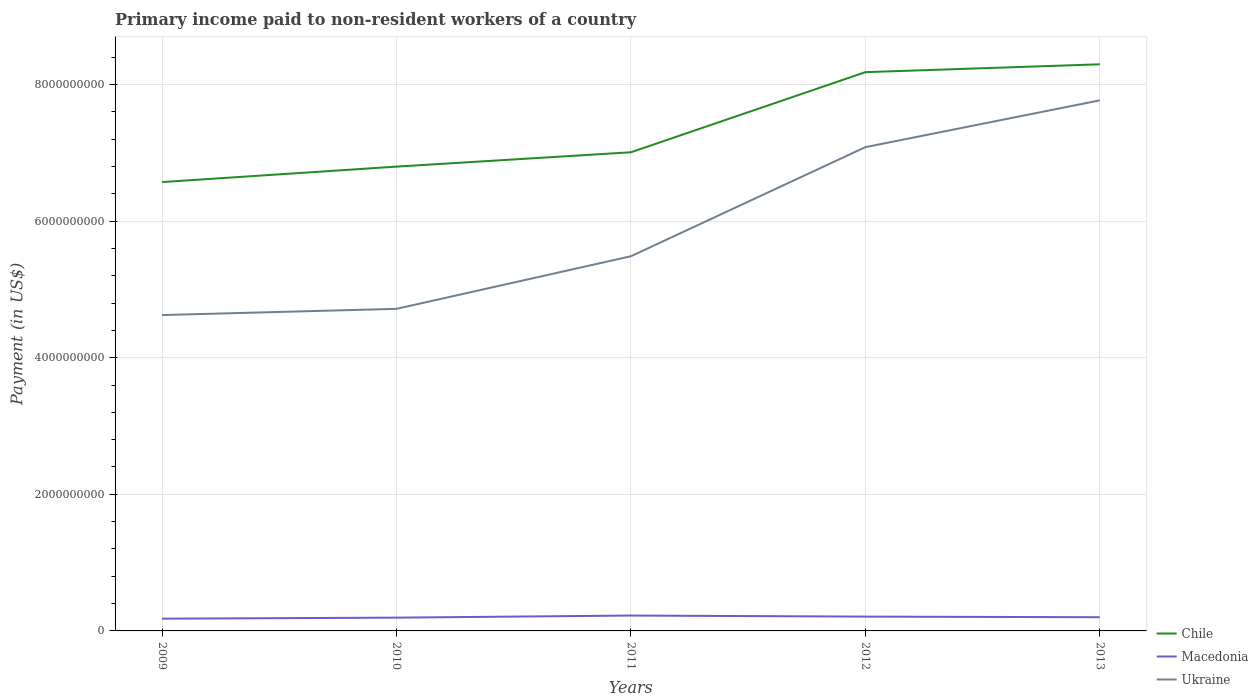Does the line corresponding to Macedonia intersect with the line corresponding to Ukraine?
Ensure brevity in your answer.  No. Across all years, what is the maximum amount paid to workers in Ukraine?
Provide a short and direct response. 4.62e+09. What is the total amount paid to workers in Macedonia in the graph?
Keep it short and to the point. 9.02e+06. What is the difference between the highest and the second highest amount paid to workers in Chile?
Your answer should be compact. 1.72e+09. Is the amount paid to workers in Ukraine strictly greater than the amount paid to workers in Macedonia over the years?
Make the answer very short. No. How many years are there in the graph?
Provide a succinct answer. 5. What is the difference between two consecutive major ticks on the Y-axis?
Keep it short and to the point. 2.00e+09. Where does the legend appear in the graph?
Your response must be concise. Bottom right. What is the title of the graph?
Your answer should be very brief. Primary income paid to non-resident workers of a country. What is the label or title of the Y-axis?
Offer a terse response. Payment (in US$). What is the Payment (in US$) in Chile in 2009?
Your answer should be compact. 6.57e+09. What is the Payment (in US$) in Macedonia in 2009?
Offer a very short reply. 1.79e+08. What is the Payment (in US$) in Ukraine in 2009?
Your response must be concise. 4.62e+09. What is the Payment (in US$) of Chile in 2010?
Your response must be concise. 6.80e+09. What is the Payment (in US$) of Macedonia in 2010?
Provide a succinct answer. 1.94e+08. What is the Payment (in US$) in Ukraine in 2010?
Give a very brief answer. 4.72e+09. What is the Payment (in US$) in Chile in 2011?
Make the answer very short. 7.01e+09. What is the Payment (in US$) in Macedonia in 2011?
Your answer should be very brief. 2.25e+08. What is the Payment (in US$) in Ukraine in 2011?
Keep it short and to the point. 5.48e+09. What is the Payment (in US$) of Chile in 2012?
Provide a short and direct response. 8.18e+09. What is the Payment (in US$) of Macedonia in 2012?
Give a very brief answer. 2.10e+08. What is the Payment (in US$) in Ukraine in 2012?
Your answer should be very brief. 7.08e+09. What is the Payment (in US$) in Chile in 2013?
Keep it short and to the point. 8.29e+09. What is the Payment (in US$) in Macedonia in 2013?
Ensure brevity in your answer.  2.01e+08. What is the Payment (in US$) in Ukraine in 2013?
Offer a very short reply. 7.77e+09. Across all years, what is the maximum Payment (in US$) in Chile?
Give a very brief answer. 8.29e+09. Across all years, what is the maximum Payment (in US$) in Macedonia?
Give a very brief answer. 2.25e+08. Across all years, what is the maximum Payment (in US$) of Ukraine?
Your response must be concise. 7.77e+09. Across all years, what is the minimum Payment (in US$) of Chile?
Offer a terse response. 6.57e+09. Across all years, what is the minimum Payment (in US$) of Macedonia?
Provide a succinct answer. 1.79e+08. Across all years, what is the minimum Payment (in US$) of Ukraine?
Your response must be concise. 4.62e+09. What is the total Payment (in US$) of Chile in the graph?
Make the answer very short. 3.68e+1. What is the total Payment (in US$) in Macedonia in the graph?
Your answer should be compact. 1.01e+09. What is the total Payment (in US$) of Ukraine in the graph?
Your answer should be compact. 2.97e+1. What is the difference between the Payment (in US$) in Chile in 2009 and that in 2010?
Your response must be concise. -2.26e+08. What is the difference between the Payment (in US$) in Macedonia in 2009 and that in 2010?
Offer a terse response. -1.49e+07. What is the difference between the Payment (in US$) in Ukraine in 2009 and that in 2010?
Keep it short and to the point. -9.10e+07. What is the difference between the Payment (in US$) of Chile in 2009 and that in 2011?
Your response must be concise. -4.36e+08. What is the difference between the Payment (in US$) in Macedonia in 2009 and that in 2011?
Keep it short and to the point. -4.56e+07. What is the difference between the Payment (in US$) of Ukraine in 2009 and that in 2011?
Ensure brevity in your answer.  -8.61e+08. What is the difference between the Payment (in US$) of Chile in 2009 and that in 2012?
Ensure brevity in your answer.  -1.61e+09. What is the difference between the Payment (in US$) in Macedonia in 2009 and that in 2012?
Provide a succinct answer. -3.01e+07. What is the difference between the Payment (in US$) in Ukraine in 2009 and that in 2012?
Offer a terse response. -2.46e+09. What is the difference between the Payment (in US$) of Chile in 2009 and that in 2013?
Your response must be concise. -1.72e+09. What is the difference between the Payment (in US$) of Macedonia in 2009 and that in 2013?
Offer a very short reply. -2.11e+07. What is the difference between the Payment (in US$) in Ukraine in 2009 and that in 2013?
Your response must be concise. -3.14e+09. What is the difference between the Payment (in US$) in Chile in 2010 and that in 2011?
Offer a terse response. -2.10e+08. What is the difference between the Payment (in US$) of Macedonia in 2010 and that in 2011?
Offer a terse response. -3.07e+07. What is the difference between the Payment (in US$) of Ukraine in 2010 and that in 2011?
Provide a short and direct response. -7.70e+08. What is the difference between the Payment (in US$) in Chile in 2010 and that in 2012?
Your answer should be very brief. -1.38e+09. What is the difference between the Payment (in US$) of Macedonia in 2010 and that in 2012?
Provide a short and direct response. -1.52e+07. What is the difference between the Payment (in US$) of Ukraine in 2010 and that in 2012?
Your response must be concise. -2.37e+09. What is the difference between the Payment (in US$) of Chile in 2010 and that in 2013?
Make the answer very short. -1.50e+09. What is the difference between the Payment (in US$) of Macedonia in 2010 and that in 2013?
Offer a very short reply. -6.19e+06. What is the difference between the Payment (in US$) of Ukraine in 2010 and that in 2013?
Your answer should be very brief. -3.05e+09. What is the difference between the Payment (in US$) of Chile in 2011 and that in 2012?
Provide a succinct answer. -1.17e+09. What is the difference between the Payment (in US$) of Macedonia in 2011 and that in 2012?
Keep it short and to the point. 1.55e+07. What is the difference between the Payment (in US$) of Ukraine in 2011 and that in 2012?
Offer a terse response. -1.60e+09. What is the difference between the Payment (in US$) in Chile in 2011 and that in 2013?
Your response must be concise. -1.29e+09. What is the difference between the Payment (in US$) in Macedonia in 2011 and that in 2013?
Give a very brief answer. 2.45e+07. What is the difference between the Payment (in US$) of Ukraine in 2011 and that in 2013?
Provide a short and direct response. -2.28e+09. What is the difference between the Payment (in US$) in Chile in 2012 and that in 2013?
Offer a terse response. -1.15e+08. What is the difference between the Payment (in US$) of Macedonia in 2012 and that in 2013?
Your answer should be very brief. 9.02e+06. What is the difference between the Payment (in US$) in Ukraine in 2012 and that in 2013?
Offer a terse response. -6.85e+08. What is the difference between the Payment (in US$) in Chile in 2009 and the Payment (in US$) in Macedonia in 2010?
Your answer should be very brief. 6.38e+09. What is the difference between the Payment (in US$) of Chile in 2009 and the Payment (in US$) of Ukraine in 2010?
Ensure brevity in your answer.  1.86e+09. What is the difference between the Payment (in US$) in Macedonia in 2009 and the Payment (in US$) in Ukraine in 2010?
Offer a very short reply. -4.54e+09. What is the difference between the Payment (in US$) in Chile in 2009 and the Payment (in US$) in Macedonia in 2011?
Ensure brevity in your answer.  6.35e+09. What is the difference between the Payment (in US$) of Chile in 2009 and the Payment (in US$) of Ukraine in 2011?
Provide a short and direct response. 1.09e+09. What is the difference between the Payment (in US$) of Macedonia in 2009 and the Payment (in US$) of Ukraine in 2011?
Provide a short and direct response. -5.31e+09. What is the difference between the Payment (in US$) of Chile in 2009 and the Payment (in US$) of Macedonia in 2012?
Make the answer very short. 6.36e+09. What is the difference between the Payment (in US$) in Chile in 2009 and the Payment (in US$) in Ukraine in 2012?
Ensure brevity in your answer.  -5.11e+08. What is the difference between the Payment (in US$) in Macedonia in 2009 and the Payment (in US$) in Ukraine in 2012?
Ensure brevity in your answer.  -6.90e+09. What is the difference between the Payment (in US$) of Chile in 2009 and the Payment (in US$) of Macedonia in 2013?
Make the answer very short. 6.37e+09. What is the difference between the Payment (in US$) in Chile in 2009 and the Payment (in US$) in Ukraine in 2013?
Provide a succinct answer. -1.20e+09. What is the difference between the Payment (in US$) of Macedonia in 2009 and the Payment (in US$) of Ukraine in 2013?
Give a very brief answer. -7.59e+09. What is the difference between the Payment (in US$) of Chile in 2010 and the Payment (in US$) of Macedonia in 2011?
Give a very brief answer. 6.57e+09. What is the difference between the Payment (in US$) of Chile in 2010 and the Payment (in US$) of Ukraine in 2011?
Provide a succinct answer. 1.31e+09. What is the difference between the Payment (in US$) of Macedonia in 2010 and the Payment (in US$) of Ukraine in 2011?
Provide a short and direct response. -5.29e+09. What is the difference between the Payment (in US$) of Chile in 2010 and the Payment (in US$) of Macedonia in 2012?
Provide a short and direct response. 6.59e+09. What is the difference between the Payment (in US$) in Chile in 2010 and the Payment (in US$) in Ukraine in 2012?
Your answer should be very brief. -2.85e+08. What is the difference between the Payment (in US$) in Macedonia in 2010 and the Payment (in US$) in Ukraine in 2012?
Your answer should be compact. -6.89e+09. What is the difference between the Payment (in US$) in Chile in 2010 and the Payment (in US$) in Macedonia in 2013?
Provide a succinct answer. 6.60e+09. What is the difference between the Payment (in US$) of Chile in 2010 and the Payment (in US$) of Ukraine in 2013?
Ensure brevity in your answer.  -9.70e+08. What is the difference between the Payment (in US$) of Macedonia in 2010 and the Payment (in US$) of Ukraine in 2013?
Offer a very short reply. -7.57e+09. What is the difference between the Payment (in US$) of Chile in 2011 and the Payment (in US$) of Macedonia in 2012?
Provide a succinct answer. 6.80e+09. What is the difference between the Payment (in US$) of Chile in 2011 and the Payment (in US$) of Ukraine in 2012?
Offer a terse response. -7.49e+07. What is the difference between the Payment (in US$) in Macedonia in 2011 and the Payment (in US$) in Ukraine in 2012?
Make the answer very short. -6.86e+09. What is the difference between the Payment (in US$) in Chile in 2011 and the Payment (in US$) in Macedonia in 2013?
Offer a very short reply. 6.81e+09. What is the difference between the Payment (in US$) of Chile in 2011 and the Payment (in US$) of Ukraine in 2013?
Give a very brief answer. -7.60e+08. What is the difference between the Payment (in US$) in Macedonia in 2011 and the Payment (in US$) in Ukraine in 2013?
Your response must be concise. -7.54e+09. What is the difference between the Payment (in US$) of Chile in 2012 and the Payment (in US$) of Macedonia in 2013?
Keep it short and to the point. 7.98e+09. What is the difference between the Payment (in US$) of Chile in 2012 and the Payment (in US$) of Ukraine in 2013?
Give a very brief answer. 4.13e+08. What is the difference between the Payment (in US$) of Macedonia in 2012 and the Payment (in US$) of Ukraine in 2013?
Give a very brief answer. -7.56e+09. What is the average Payment (in US$) in Chile per year?
Your response must be concise. 7.37e+09. What is the average Payment (in US$) of Macedonia per year?
Offer a terse response. 2.02e+08. What is the average Payment (in US$) in Ukraine per year?
Provide a succinct answer. 5.93e+09. In the year 2009, what is the difference between the Payment (in US$) of Chile and Payment (in US$) of Macedonia?
Provide a succinct answer. 6.39e+09. In the year 2009, what is the difference between the Payment (in US$) in Chile and Payment (in US$) in Ukraine?
Provide a short and direct response. 1.95e+09. In the year 2009, what is the difference between the Payment (in US$) of Macedonia and Payment (in US$) of Ukraine?
Your answer should be very brief. -4.44e+09. In the year 2010, what is the difference between the Payment (in US$) in Chile and Payment (in US$) in Macedonia?
Offer a very short reply. 6.60e+09. In the year 2010, what is the difference between the Payment (in US$) of Chile and Payment (in US$) of Ukraine?
Ensure brevity in your answer.  2.08e+09. In the year 2010, what is the difference between the Payment (in US$) in Macedonia and Payment (in US$) in Ukraine?
Provide a succinct answer. -4.52e+09. In the year 2011, what is the difference between the Payment (in US$) of Chile and Payment (in US$) of Macedonia?
Offer a terse response. 6.78e+09. In the year 2011, what is the difference between the Payment (in US$) of Chile and Payment (in US$) of Ukraine?
Provide a short and direct response. 1.52e+09. In the year 2011, what is the difference between the Payment (in US$) of Macedonia and Payment (in US$) of Ukraine?
Provide a short and direct response. -5.26e+09. In the year 2012, what is the difference between the Payment (in US$) of Chile and Payment (in US$) of Macedonia?
Offer a very short reply. 7.97e+09. In the year 2012, what is the difference between the Payment (in US$) of Chile and Payment (in US$) of Ukraine?
Provide a short and direct response. 1.10e+09. In the year 2012, what is the difference between the Payment (in US$) of Macedonia and Payment (in US$) of Ukraine?
Make the answer very short. -6.87e+09. In the year 2013, what is the difference between the Payment (in US$) in Chile and Payment (in US$) in Macedonia?
Offer a terse response. 8.09e+09. In the year 2013, what is the difference between the Payment (in US$) in Chile and Payment (in US$) in Ukraine?
Your answer should be very brief. 5.28e+08. In the year 2013, what is the difference between the Payment (in US$) of Macedonia and Payment (in US$) of Ukraine?
Your answer should be compact. -7.57e+09. What is the ratio of the Payment (in US$) of Chile in 2009 to that in 2010?
Offer a terse response. 0.97. What is the ratio of the Payment (in US$) of Macedonia in 2009 to that in 2010?
Offer a terse response. 0.92. What is the ratio of the Payment (in US$) in Ukraine in 2009 to that in 2010?
Give a very brief answer. 0.98. What is the ratio of the Payment (in US$) in Chile in 2009 to that in 2011?
Provide a short and direct response. 0.94. What is the ratio of the Payment (in US$) in Macedonia in 2009 to that in 2011?
Provide a short and direct response. 0.8. What is the ratio of the Payment (in US$) of Ukraine in 2009 to that in 2011?
Offer a very short reply. 0.84. What is the ratio of the Payment (in US$) of Chile in 2009 to that in 2012?
Offer a terse response. 0.8. What is the ratio of the Payment (in US$) in Macedonia in 2009 to that in 2012?
Your answer should be very brief. 0.86. What is the ratio of the Payment (in US$) of Ukraine in 2009 to that in 2012?
Your answer should be compact. 0.65. What is the ratio of the Payment (in US$) in Chile in 2009 to that in 2013?
Your answer should be compact. 0.79. What is the ratio of the Payment (in US$) in Macedonia in 2009 to that in 2013?
Your answer should be very brief. 0.89. What is the ratio of the Payment (in US$) in Ukraine in 2009 to that in 2013?
Keep it short and to the point. 0.6. What is the ratio of the Payment (in US$) of Macedonia in 2010 to that in 2011?
Your answer should be very brief. 0.86. What is the ratio of the Payment (in US$) of Ukraine in 2010 to that in 2011?
Your response must be concise. 0.86. What is the ratio of the Payment (in US$) in Chile in 2010 to that in 2012?
Ensure brevity in your answer.  0.83. What is the ratio of the Payment (in US$) in Macedonia in 2010 to that in 2012?
Provide a short and direct response. 0.93. What is the ratio of the Payment (in US$) of Ukraine in 2010 to that in 2012?
Give a very brief answer. 0.67. What is the ratio of the Payment (in US$) in Chile in 2010 to that in 2013?
Give a very brief answer. 0.82. What is the ratio of the Payment (in US$) of Macedonia in 2010 to that in 2013?
Offer a terse response. 0.97. What is the ratio of the Payment (in US$) in Ukraine in 2010 to that in 2013?
Your answer should be compact. 0.61. What is the ratio of the Payment (in US$) of Chile in 2011 to that in 2012?
Provide a succinct answer. 0.86. What is the ratio of the Payment (in US$) of Macedonia in 2011 to that in 2012?
Your answer should be very brief. 1.07. What is the ratio of the Payment (in US$) in Ukraine in 2011 to that in 2012?
Offer a terse response. 0.77. What is the ratio of the Payment (in US$) of Chile in 2011 to that in 2013?
Your answer should be compact. 0.84. What is the ratio of the Payment (in US$) of Macedonia in 2011 to that in 2013?
Offer a very short reply. 1.12. What is the ratio of the Payment (in US$) in Ukraine in 2011 to that in 2013?
Give a very brief answer. 0.71. What is the ratio of the Payment (in US$) of Chile in 2012 to that in 2013?
Ensure brevity in your answer.  0.99. What is the ratio of the Payment (in US$) in Macedonia in 2012 to that in 2013?
Offer a terse response. 1.04. What is the ratio of the Payment (in US$) in Ukraine in 2012 to that in 2013?
Give a very brief answer. 0.91. What is the difference between the highest and the second highest Payment (in US$) in Chile?
Your answer should be compact. 1.15e+08. What is the difference between the highest and the second highest Payment (in US$) of Macedonia?
Keep it short and to the point. 1.55e+07. What is the difference between the highest and the second highest Payment (in US$) in Ukraine?
Give a very brief answer. 6.85e+08. What is the difference between the highest and the lowest Payment (in US$) in Chile?
Your answer should be very brief. 1.72e+09. What is the difference between the highest and the lowest Payment (in US$) of Macedonia?
Give a very brief answer. 4.56e+07. What is the difference between the highest and the lowest Payment (in US$) of Ukraine?
Keep it short and to the point. 3.14e+09. 